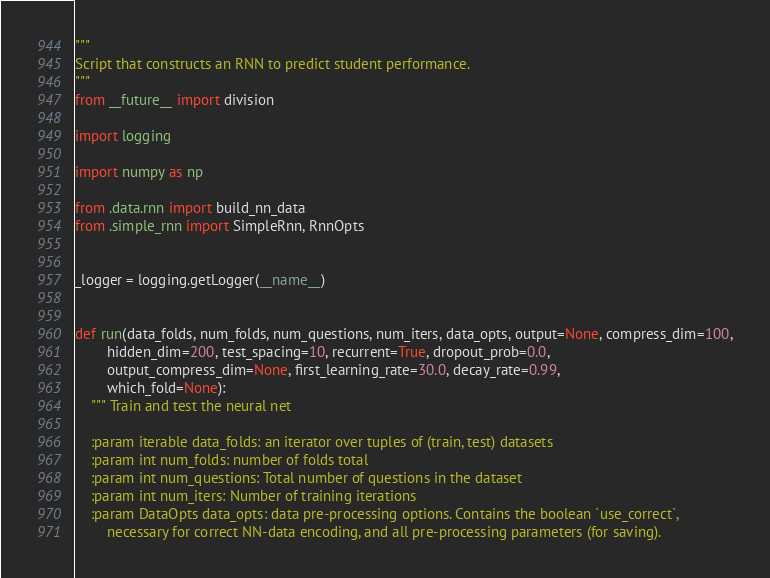Convert code to text. <code><loc_0><loc_0><loc_500><loc_500><_Python_>"""
Script that constructs an RNN to predict student performance.
"""
from __future__ import division

import logging

import numpy as np

from .data.rnn import build_nn_data
from .simple_rnn import SimpleRnn, RnnOpts


_logger = logging.getLogger(__name__)


def run(data_folds, num_folds, num_questions, num_iters, data_opts, output=None, compress_dim=100,
        hidden_dim=200, test_spacing=10, recurrent=True, dropout_prob=0.0,
        output_compress_dim=None, first_learning_rate=30.0, decay_rate=0.99,
        which_fold=None):
    """ Train and test the neural net

    :param iterable data_folds: an iterator over tuples of (train, test) datasets
    :param int num_folds: number of folds total
    :param int num_questions: Total number of questions in the dataset
    :param int num_iters: Number of training iterations
    :param DataOpts data_opts: data pre-processing options. Contains the boolean `use_correct`,
        necessary for correct NN-data encoding, and all pre-processing parameters (for saving).</code> 